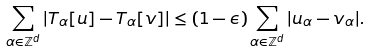<formula> <loc_0><loc_0><loc_500><loc_500>\sum _ { \alpha \in \mathbb { Z } ^ { d } } | T _ { \alpha } [ u ] - T _ { \alpha } [ v ] | \leq ( 1 - \epsilon ) \sum _ { \alpha \in \mathbb { Z } ^ { d } } | u _ { \alpha } - v _ { \alpha } | .</formula> 